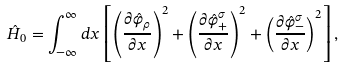<formula> <loc_0><loc_0><loc_500><loc_500>\hat { H } _ { 0 } = \int _ { - \infty } ^ { \infty } d x \left [ \left ( \frac { \partial \hat { \varphi } _ { \rho } } { \partial x } \right ) ^ { 2 } + \left ( \frac { \partial \hat { \varphi } _ { + } ^ { \sigma } } { \partial x } \right ) ^ { 2 } + \left ( \frac { \partial \hat { \varphi } _ { - } ^ { \sigma } } { \partial x } \right ) ^ { 2 } \right ] ,</formula> 